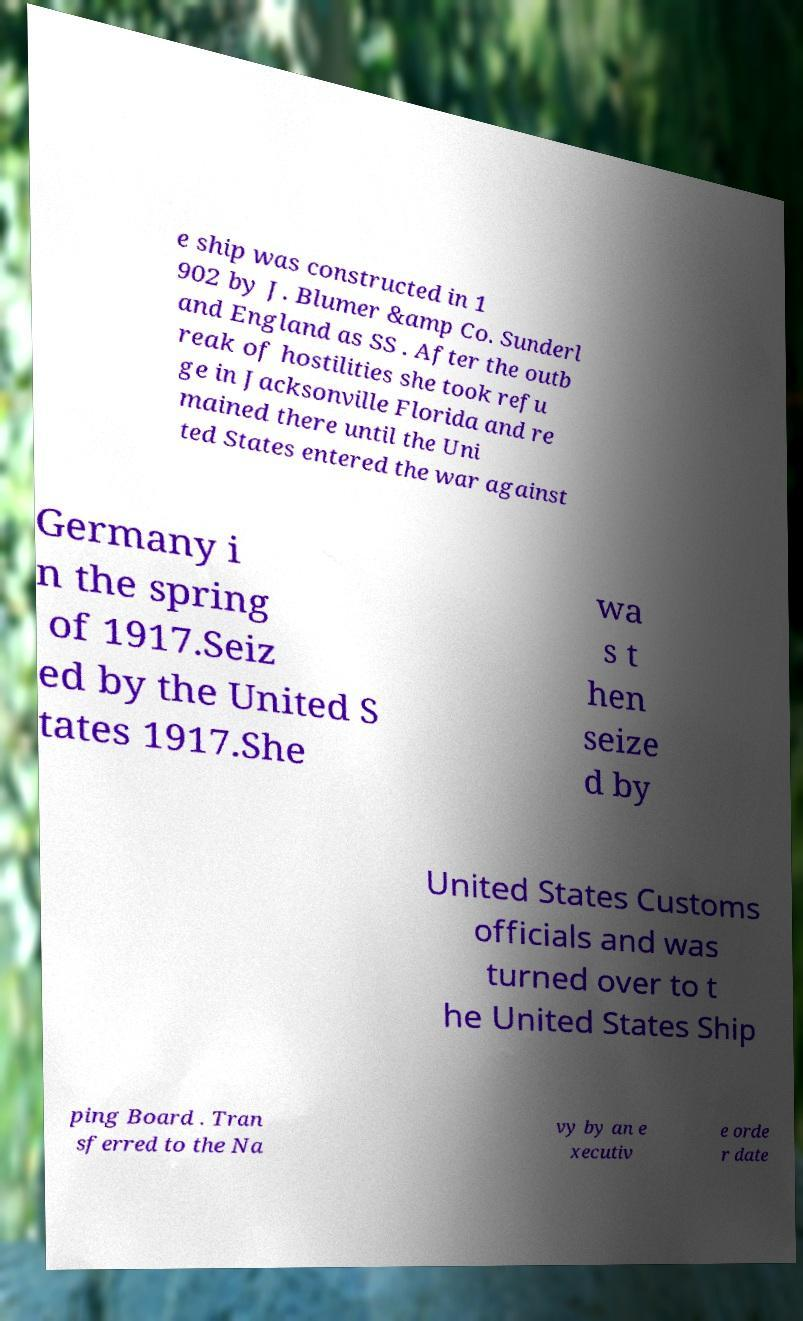Can you read and provide the text displayed in the image?This photo seems to have some interesting text. Can you extract and type it out for me? e ship was constructed in 1 902 by J. Blumer &amp Co. Sunderl and England as SS . After the outb reak of hostilities she took refu ge in Jacksonville Florida and re mained there until the Uni ted States entered the war against Germany i n the spring of 1917.Seiz ed by the United S tates 1917.She wa s t hen seize d by United States Customs officials and was turned over to t he United States Ship ping Board . Tran sferred to the Na vy by an e xecutiv e orde r date 